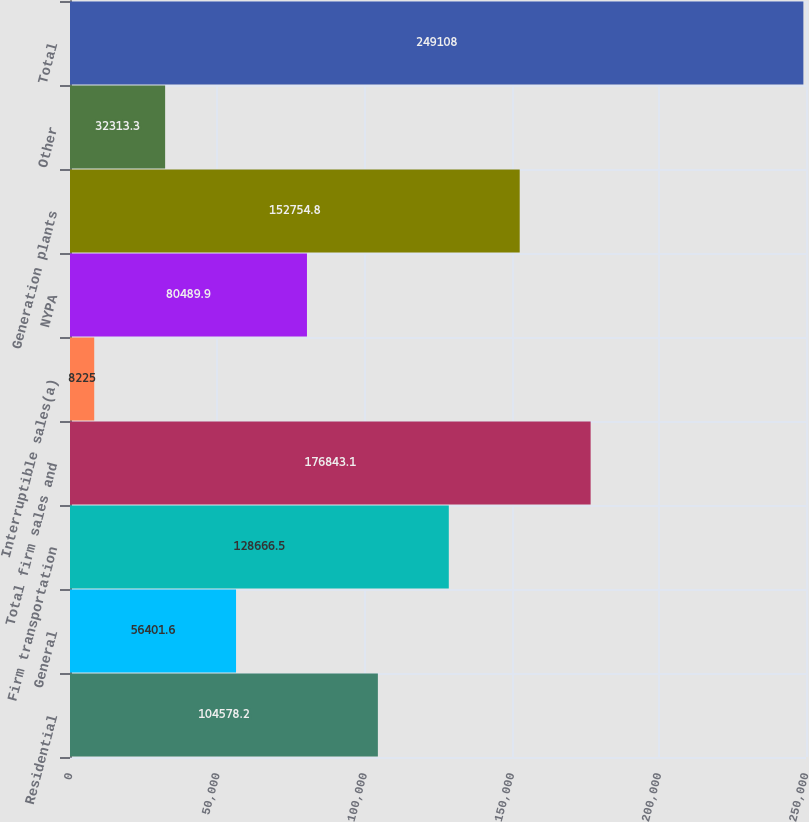Convert chart to OTSL. <chart><loc_0><loc_0><loc_500><loc_500><bar_chart><fcel>Residential<fcel>General<fcel>Firm transportation<fcel>Total firm sales and<fcel>Interruptible sales(a)<fcel>NYPA<fcel>Generation plants<fcel>Other<fcel>Total<nl><fcel>104578<fcel>56401.6<fcel>128666<fcel>176843<fcel>8225<fcel>80489.9<fcel>152755<fcel>32313.3<fcel>249108<nl></chart> 